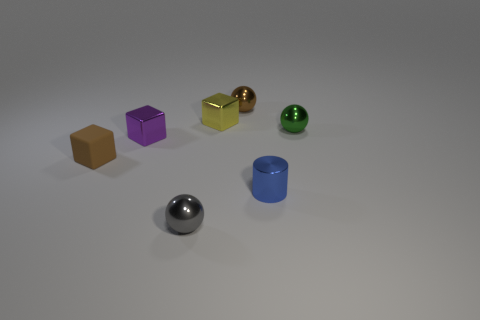There is a small metallic thing that is left of the ball in front of the small purple shiny block; what is its shape?
Make the answer very short. Cube. There is a gray metallic thing that is the same size as the rubber object; what is its shape?
Make the answer very short. Sphere. Is there another tiny thing that has the same color as the small matte object?
Provide a succinct answer. Yes. Are there an equal number of blue metal things that are left of the blue thing and small cubes in front of the tiny green metallic thing?
Your answer should be very brief. No. There is a small purple object; does it have the same shape as the tiny brown thing behind the tiny brown matte thing?
Keep it short and to the point. No. What number of other things are made of the same material as the brown cube?
Ensure brevity in your answer.  0. There is a brown matte block; are there any gray objects on the left side of it?
Keep it short and to the point. No. What color is the sphere that is left of the metallic thing behind the yellow metal cube?
Keep it short and to the point. Gray. The metallic object that is both on the left side of the yellow metal cube and behind the tiny blue thing is what color?
Your answer should be compact. Purple. Does the tiny metallic object that is behind the yellow metallic thing have the same color as the matte cube?
Your answer should be very brief. Yes. 